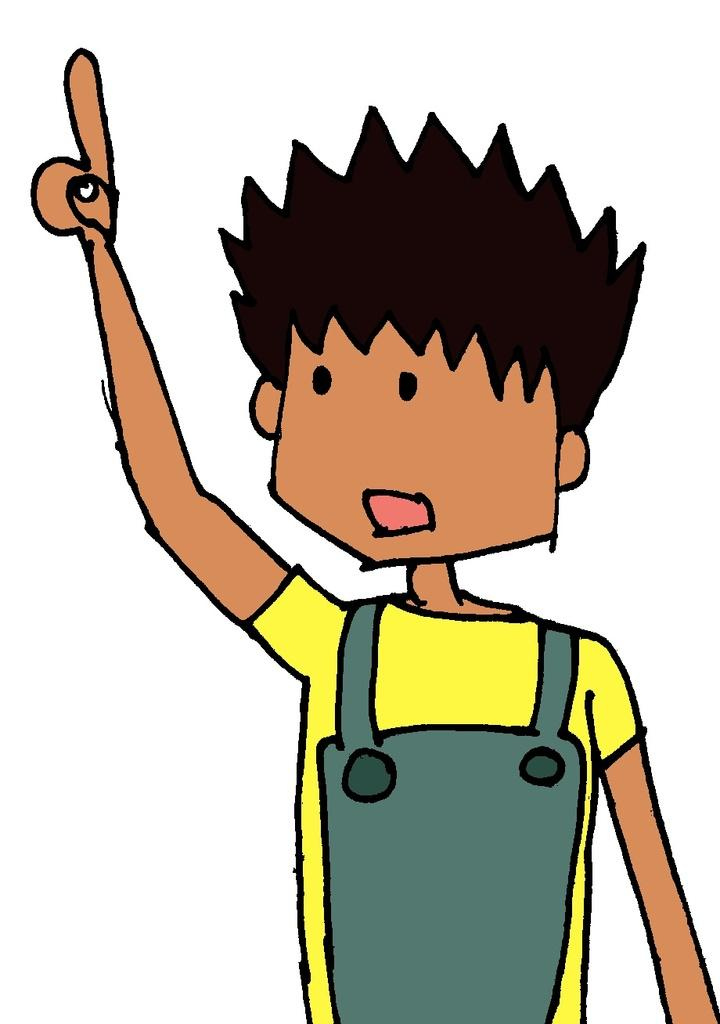What type of image is depicted in the picture? The image contains a cartoon picture. Can you describe the person in the cartoon picture? The person in the cartoon picture is wearing a yellow and green color dress. What is the name of the lamp in the image? There is no lamp present in the image; it is a cartoon picture of a person wearing a yellow and green color dress. 